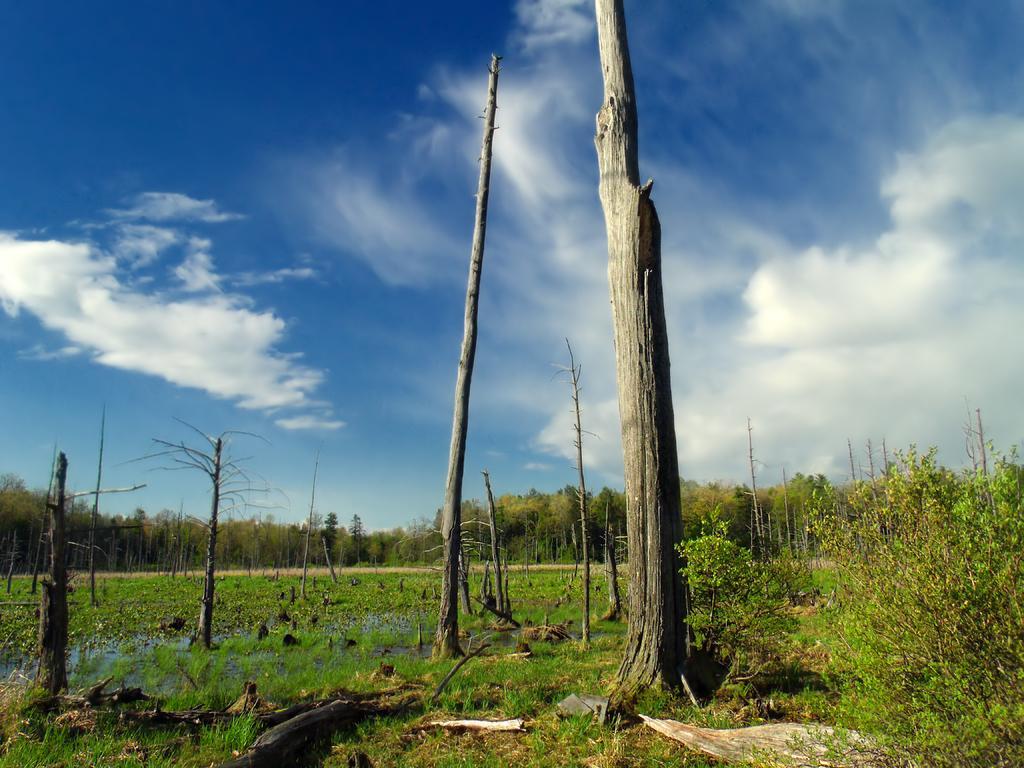How would you summarize this image in a sentence or two? In this image there are few trees and few trunks of the trees, plants, a few sticks on the ground, grass and some clouds in the sky. 